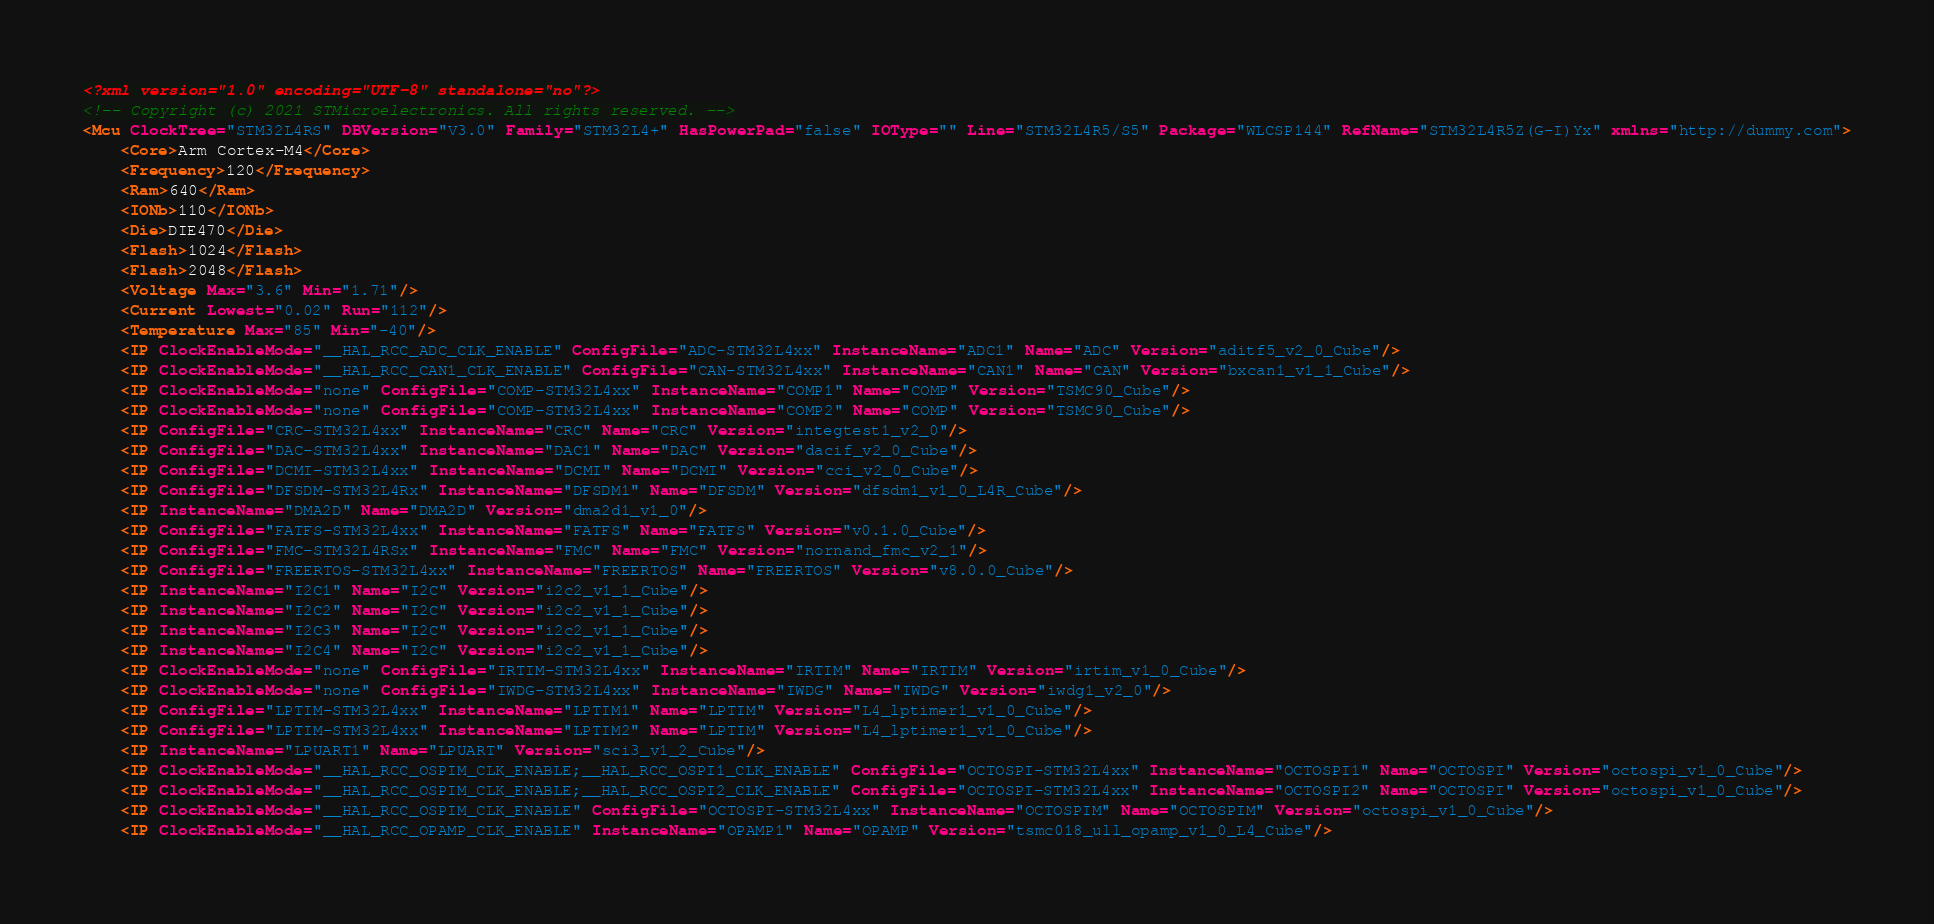Convert code to text. <code><loc_0><loc_0><loc_500><loc_500><_XML_><?xml version="1.0" encoding="UTF-8" standalone="no"?>
<!-- Copyright (c) 2021 STMicroelectronics. All rights reserved. -->
<Mcu ClockTree="STM32L4RS" DBVersion="V3.0" Family="STM32L4+" HasPowerPad="false" IOType="" Line="STM32L4R5/S5" Package="WLCSP144" RefName="STM32L4R5Z(G-I)Yx" xmlns="http://dummy.com">
	<Core>Arm Cortex-M4</Core>
	<Frequency>120</Frequency>
	<Ram>640</Ram>
	<IONb>110</IONb>
	<Die>DIE470</Die>
	<Flash>1024</Flash>
	<Flash>2048</Flash>
	<Voltage Max="3.6" Min="1.71"/>
	<Current Lowest="0.02" Run="112"/>
	<Temperature Max="85" Min="-40"/>
	<IP ClockEnableMode="__HAL_RCC_ADC_CLK_ENABLE" ConfigFile="ADC-STM32L4xx" InstanceName="ADC1" Name="ADC" Version="aditf5_v2_0_Cube"/>
	<IP ClockEnableMode="__HAL_RCC_CAN1_CLK_ENABLE" ConfigFile="CAN-STM32L4xx" InstanceName="CAN1" Name="CAN" Version="bxcan1_v1_1_Cube"/>
	<IP ClockEnableMode="none" ConfigFile="COMP-STM32L4xx" InstanceName="COMP1" Name="COMP" Version="TSMC90_Cube"/>
	<IP ClockEnableMode="none" ConfigFile="COMP-STM32L4xx" InstanceName="COMP2" Name="COMP" Version="TSMC90_Cube"/>
	<IP ConfigFile="CRC-STM32L4xx" InstanceName="CRC" Name="CRC" Version="integtest1_v2_0"/>
	<IP ConfigFile="DAC-STM32L4xx" InstanceName="DAC1" Name="DAC" Version="dacif_v2_0_Cube"/>
	<IP ConfigFile="DCMI-STM32L4xx" InstanceName="DCMI" Name="DCMI" Version="cci_v2_0_Cube"/>
	<IP ConfigFile="DFSDM-STM32L4Rx" InstanceName="DFSDM1" Name="DFSDM" Version="dfsdm1_v1_0_L4R_Cube"/>
	<IP InstanceName="DMA2D" Name="DMA2D" Version="dma2d1_v1_0"/>
	<IP ConfigFile="FATFS-STM32L4xx" InstanceName="FATFS" Name="FATFS" Version="v0.1.0_Cube"/>
	<IP ConfigFile="FMC-STM32L4RSx" InstanceName="FMC" Name="FMC" Version="nornand_fmc_v2_1"/>
	<IP ConfigFile="FREERTOS-STM32L4xx" InstanceName="FREERTOS" Name="FREERTOS" Version="v8.0.0_Cube"/>
	<IP InstanceName="I2C1" Name="I2C" Version="i2c2_v1_1_Cube"/>
	<IP InstanceName="I2C2" Name="I2C" Version="i2c2_v1_1_Cube"/>
	<IP InstanceName="I2C3" Name="I2C" Version="i2c2_v1_1_Cube"/>
	<IP InstanceName="I2C4" Name="I2C" Version="i2c2_v1_1_Cube"/>
	<IP ClockEnableMode="none" ConfigFile="IRTIM-STM32L4xx" InstanceName="IRTIM" Name="IRTIM" Version="irtim_v1_0_Cube"/>
	<IP ClockEnableMode="none" ConfigFile="IWDG-STM32L4xx" InstanceName="IWDG" Name="IWDG" Version="iwdg1_v2_0"/>
	<IP ConfigFile="LPTIM-STM32L4xx" InstanceName="LPTIM1" Name="LPTIM" Version="L4_lptimer1_v1_0_Cube"/>
	<IP ConfigFile="LPTIM-STM32L4xx" InstanceName="LPTIM2" Name="LPTIM" Version="L4_lptimer1_v1_0_Cube"/>
	<IP InstanceName="LPUART1" Name="LPUART" Version="sci3_v1_2_Cube"/>
	<IP ClockEnableMode="__HAL_RCC_OSPIM_CLK_ENABLE;__HAL_RCC_OSPI1_CLK_ENABLE" ConfigFile="OCTOSPI-STM32L4xx" InstanceName="OCTOSPI1" Name="OCTOSPI" Version="octospi_v1_0_Cube"/>
	<IP ClockEnableMode="__HAL_RCC_OSPIM_CLK_ENABLE;__HAL_RCC_OSPI2_CLK_ENABLE" ConfigFile="OCTOSPI-STM32L4xx" InstanceName="OCTOSPI2" Name="OCTOSPI" Version="octospi_v1_0_Cube"/>
	<IP ClockEnableMode="__HAL_RCC_OSPIM_CLK_ENABLE" ConfigFile="OCTOSPI-STM32L4xx" InstanceName="OCTOSPIM" Name="OCTOSPIM" Version="octospi_v1_0_Cube"/>
	<IP ClockEnableMode="__HAL_RCC_OPAMP_CLK_ENABLE" InstanceName="OPAMP1" Name="OPAMP" Version="tsmc018_ull_opamp_v1_0_L4_Cube"/></code> 